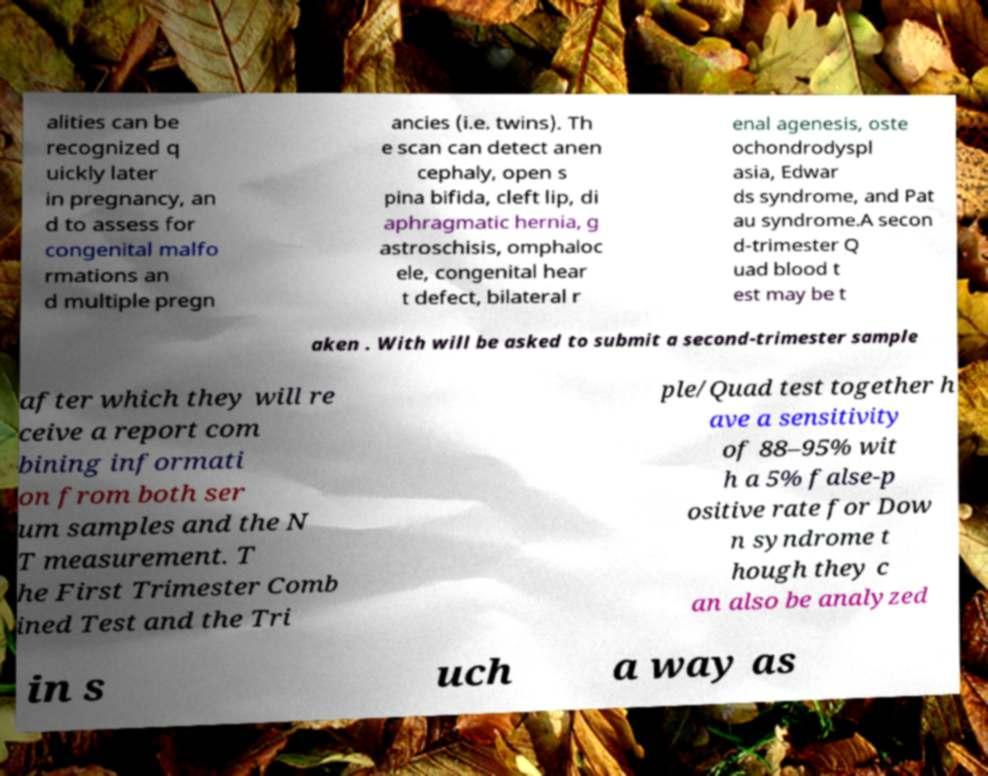Could you assist in decoding the text presented in this image and type it out clearly? alities can be recognized q uickly later in pregnancy, an d to assess for congenital malfo rmations an d multiple pregn ancies (i.e. twins). Th e scan can detect anen cephaly, open s pina bifida, cleft lip, di aphragmatic hernia, g astroschisis, omphaloc ele, congenital hear t defect, bilateral r enal agenesis, oste ochondrodyspl asia, Edwar ds syndrome, and Pat au syndrome.A secon d-trimester Q uad blood t est may be t aken . With will be asked to submit a second-trimester sample after which they will re ceive a report com bining informati on from both ser um samples and the N T measurement. T he First Trimester Comb ined Test and the Tri ple/Quad test together h ave a sensitivity of 88–95% wit h a 5% false-p ositive rate for Dow n syndrome t hough they c an also be analyzed in s uch a way as 